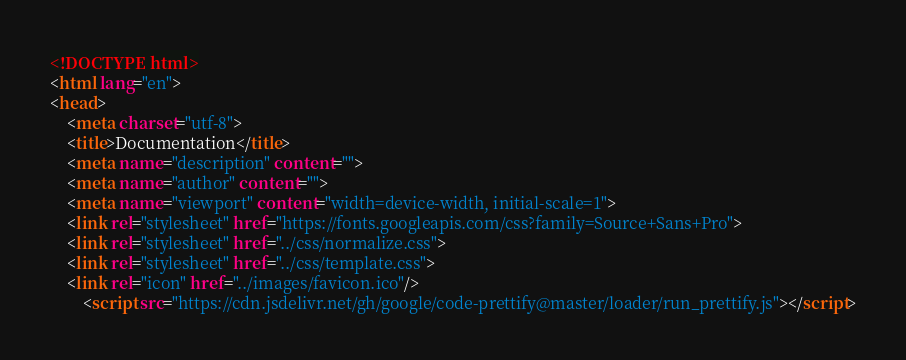Convert code to text. <code><loc_0><loc_0><loc_500><loc_500><_HTML_><!DOCTYPE html>
<html lang="en">
<head>
    <meta charset="utf-8">
    <title>Documentation</title>
    <meta name="description" content="">
    <meta name="author" content="">
    <meta name="viewport" content="width=device-width, initial-scale=1">
    <link rel="stylesheet" href="https://fonts.googleapis.com/css?family=Source+Sans+Pro">
    <link rel="stylesheet" href="../css/normalize.css">
    <link rel="stylesheet" href="../css/template.css">
    <link rel="icon" href="../images/favicon.ico"/>
        <script src="https://cdn.jsdelivr.net/gh/google/code-prettify@master/loader/run_prettify.js"></script></code> 